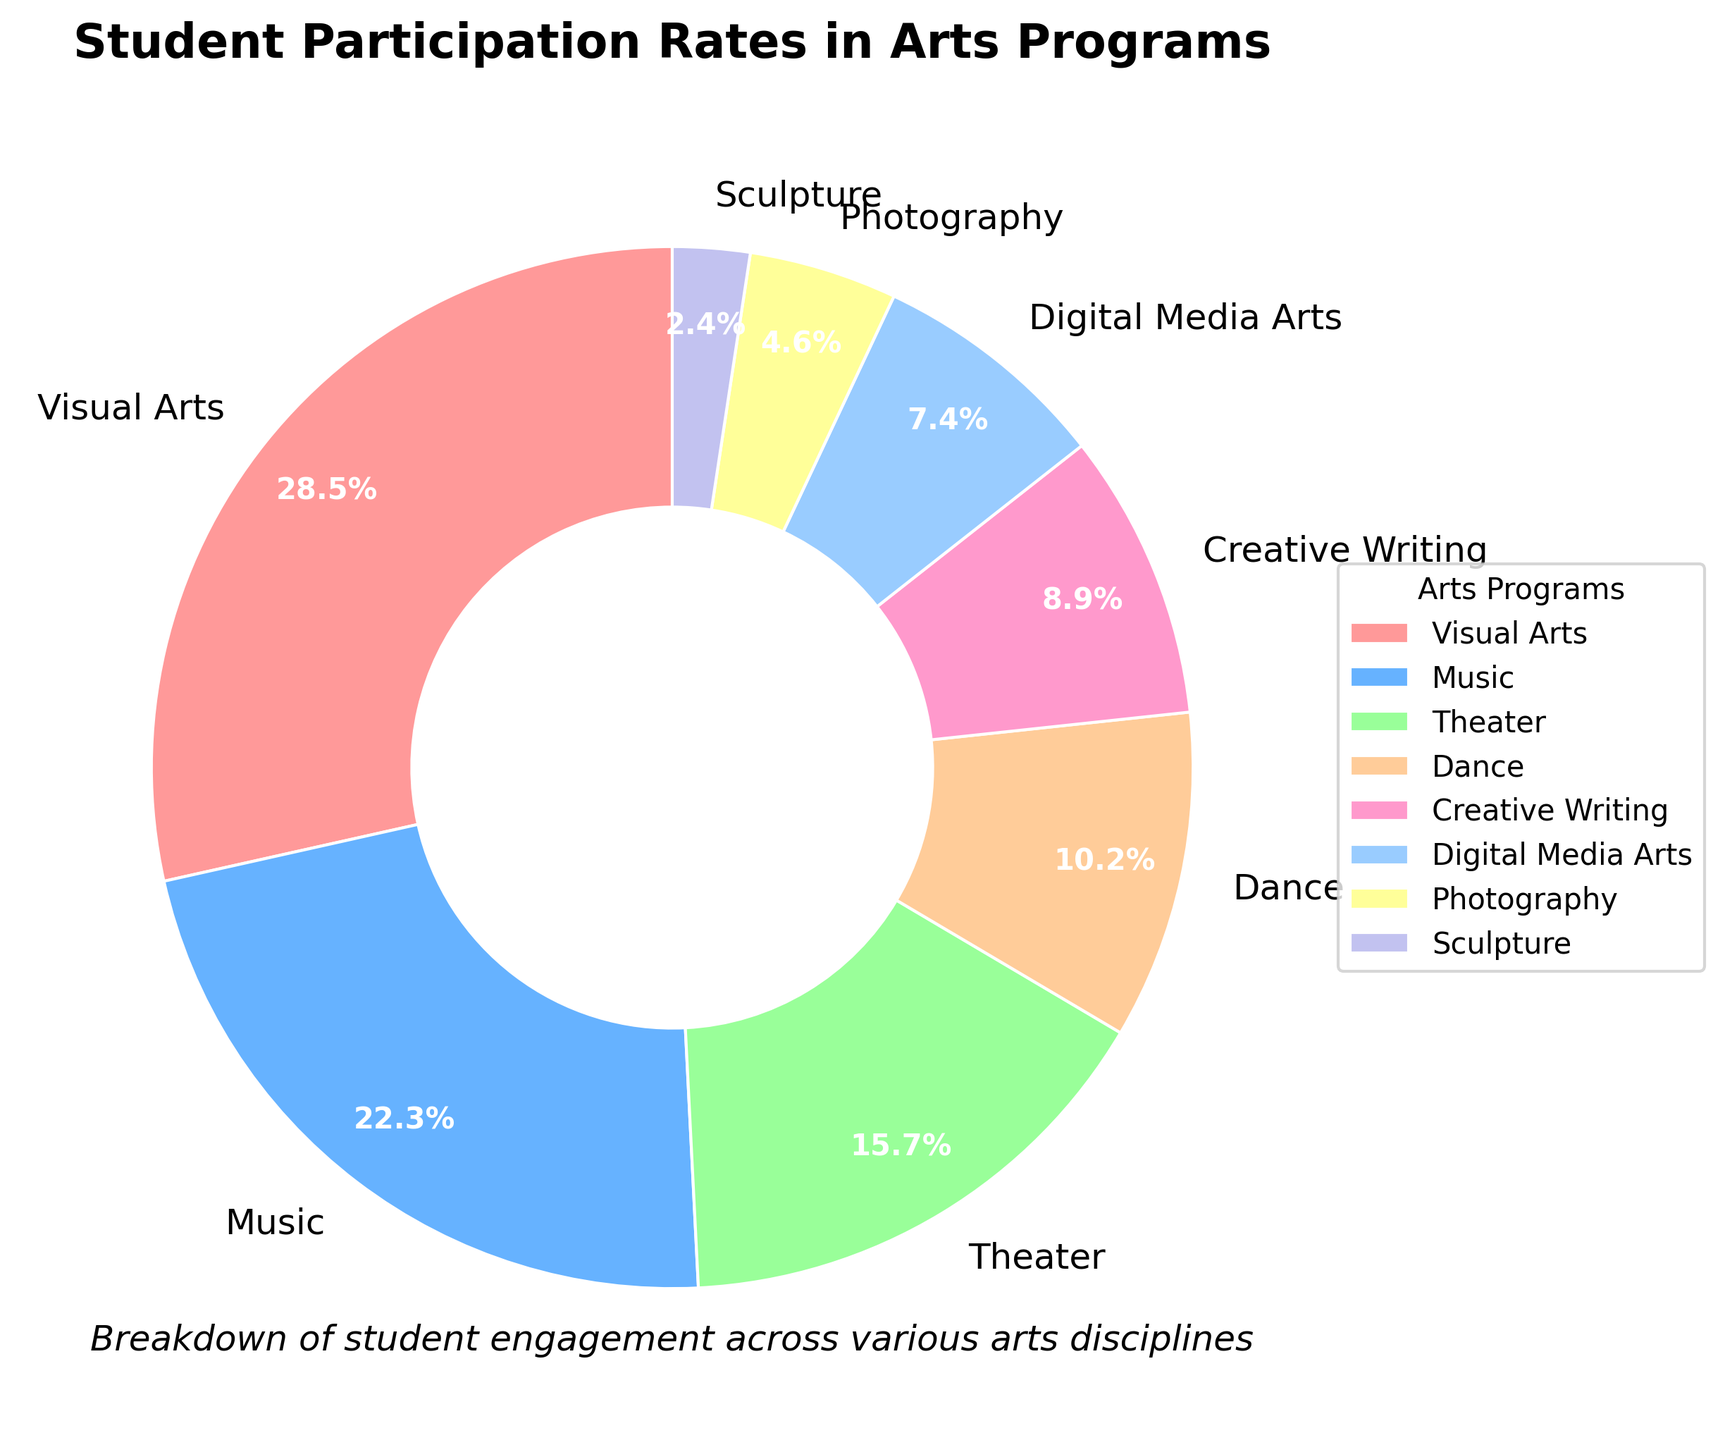What percentage of students are participating in Visual Arts? From the pie chart, we can see the participation rate of Visual Arts labeled on the slice.
Answer: 28.5% Which program has the lowest participation rate? The smallest slice of the pie chart corresponds to Sculpture, indicating it has the lowest rate.
Answer: Sculpture Compare the participation rates of Music and Dance. Which is higher, and by how much? From the chart, Music participation is 22.3% and Dance is 10.2%. Subtract Dance's rate from Music's rate: 22.3% - 10.2% = 12.1%.
Answer: Music by 12.1% What is the total participation rate of programs related to performing arts (Music, Theater, Dance)? Sum up the participation rates for Music (22.3%), Theater (15.7%), and Dance (10.2%). 22.3% + 15.7% + 10.2% = 48.2%.
Answer: 48.2% What proportion of the total participation is in Creative Writing and Digital Media Arts combined? Add participation rates of Creative Writing (8.9%) and Digital Media Arts (7.4%). 8.9% + 7.4% = 16.3%.
Answer: 16.3% Which program has the second-highest participation rate? Identify the program with the second-largest slice in the pie chart. Music is 22.3%, just below Visual Arts.
Answer: Music How does the participation rate of Theater compare to Photography and Sculpture combined? Sum the participation rates of Photography (4.6%) and Sculpture (2.4%). 4.6% + 2.4% = 7%. Compare 15.7% (Theater) to 7%. 15.7% is greater than 7%.
Answer: Theater is higher Which two programs have a combined participation rate closest to 30%? Sum the participation rates of various combinations until finding the closest to 30%. Dance (10.2%) + Theater (15.7%) = 25.9% is closest.
Answer: Dance and Theater Is the participation rate in Digital Media Arts more than half of the rate in Visual Arts? Compare half of Visual Arts' rate (28.5% / 2 = 14.25%) with Digital Media Arts (7.4%). 7.4% is less than 14.25%.
Answer: No What is the difference in participation rates between Photography and Digital Media Arts? Subtract Photography's rate (4.6%) from Digital Media Arts' rate (7.4%). 7.4% - 4.6% = 2.8%.
Answer: 2.8% 